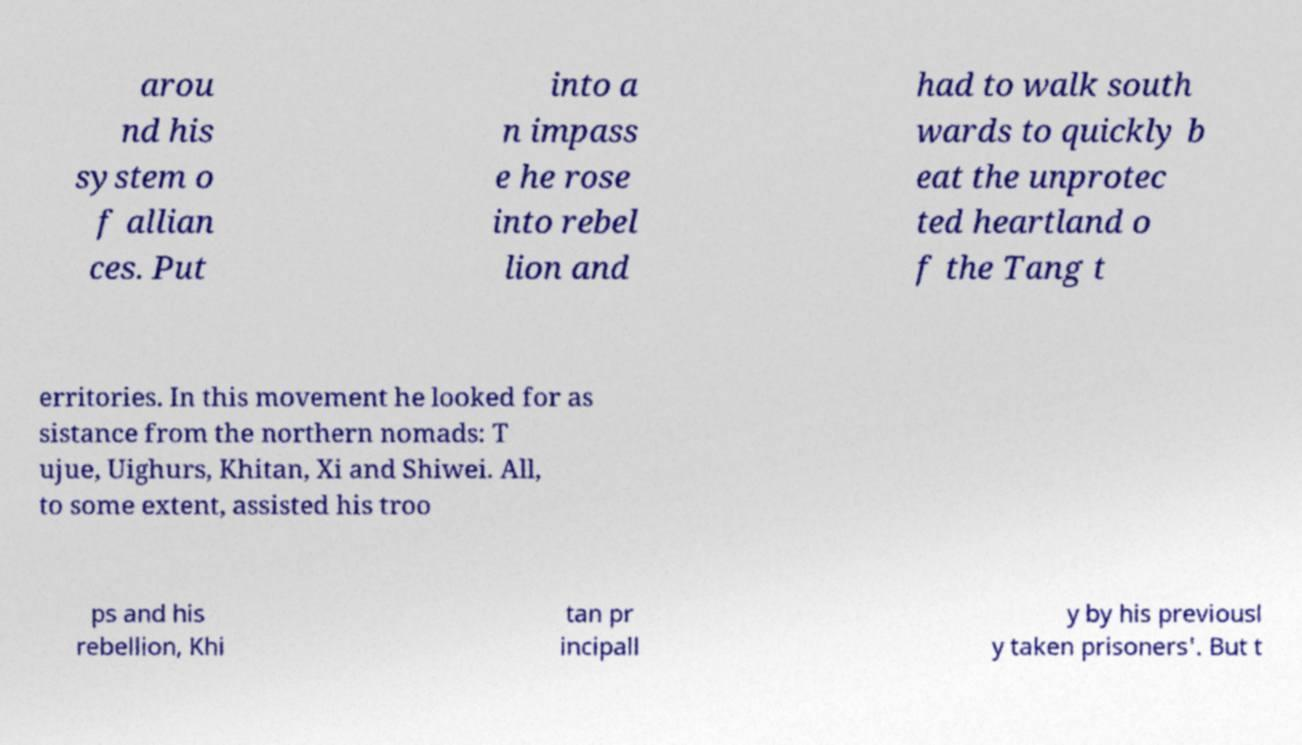There's text embedded in this image that I need extracted. Can you transcribe it verbatim? arou nd his system o f allian ces. Put into a n impass e he rose into rebel lion and had to walk south wards to quickly b eat the unprotec ted heartland o f the Tang t erritories. In this movement he looked for as sistance from the northern nomads: T ujue, Uighurs, Khitan, Xi and Shiwei. All, to some extent, assisted his troo ps and his rebellion, Khi tan pr incipall y by his previousl y taken prisoners'. But t 